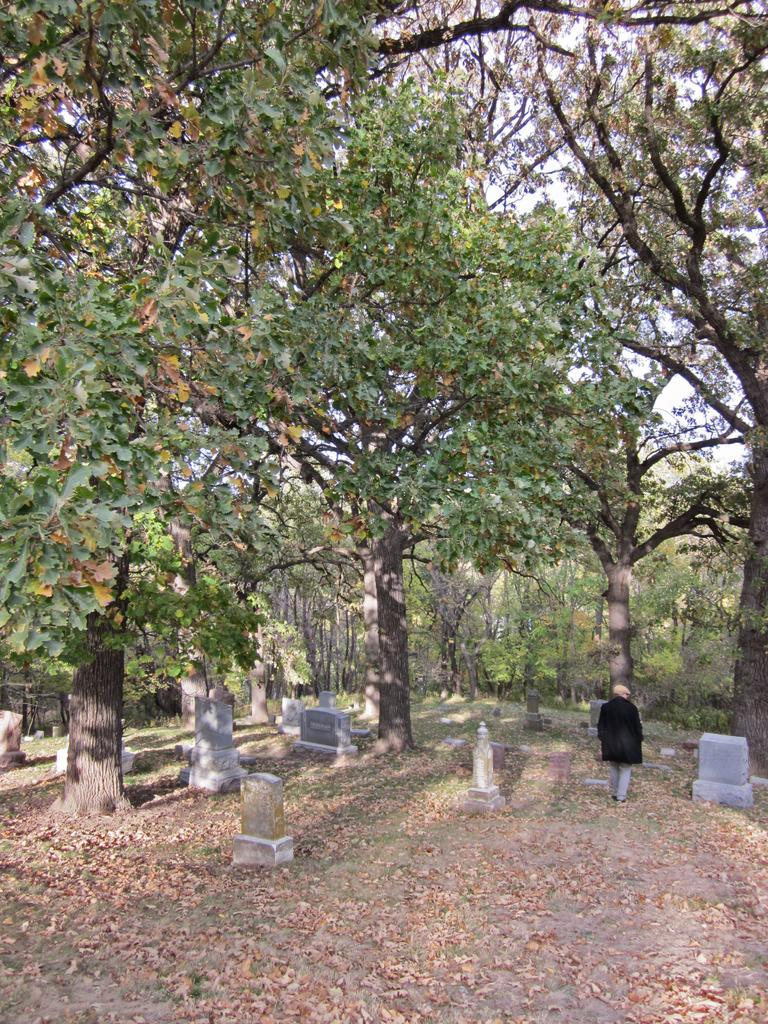What type of location is depicted in the image? There is a graveyard in the image. What can be found in the graveyard? There are gravestones in the graveyard. Is there anyone else present in the image? Yes, there is a person in the graveyard. What else can be seen in the graveyard besides gravestones? There are trees in the graveyard. What is visible in the background of the image? The sky is visible in the background of the image. How far away is the rain visible in the image? There is no rain visible in the image; only the sky is visible in the background. Can you tell me how high the person is flying in the image? There is no person flying in the image; the person is standing on the ground in the graveyard. 